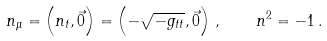Convert formula to latex. <formula><loc_0><loc_0><loc_500><loc_500>n _ { \mu } = \left ( n _ { t } , \vec { 0 } \right ) = \left ( - \sqrt { - g _ { t t } } , \vec { 0 } \right ) \, , \quad n ^ { 2 } = - 1 \, .</formula> 